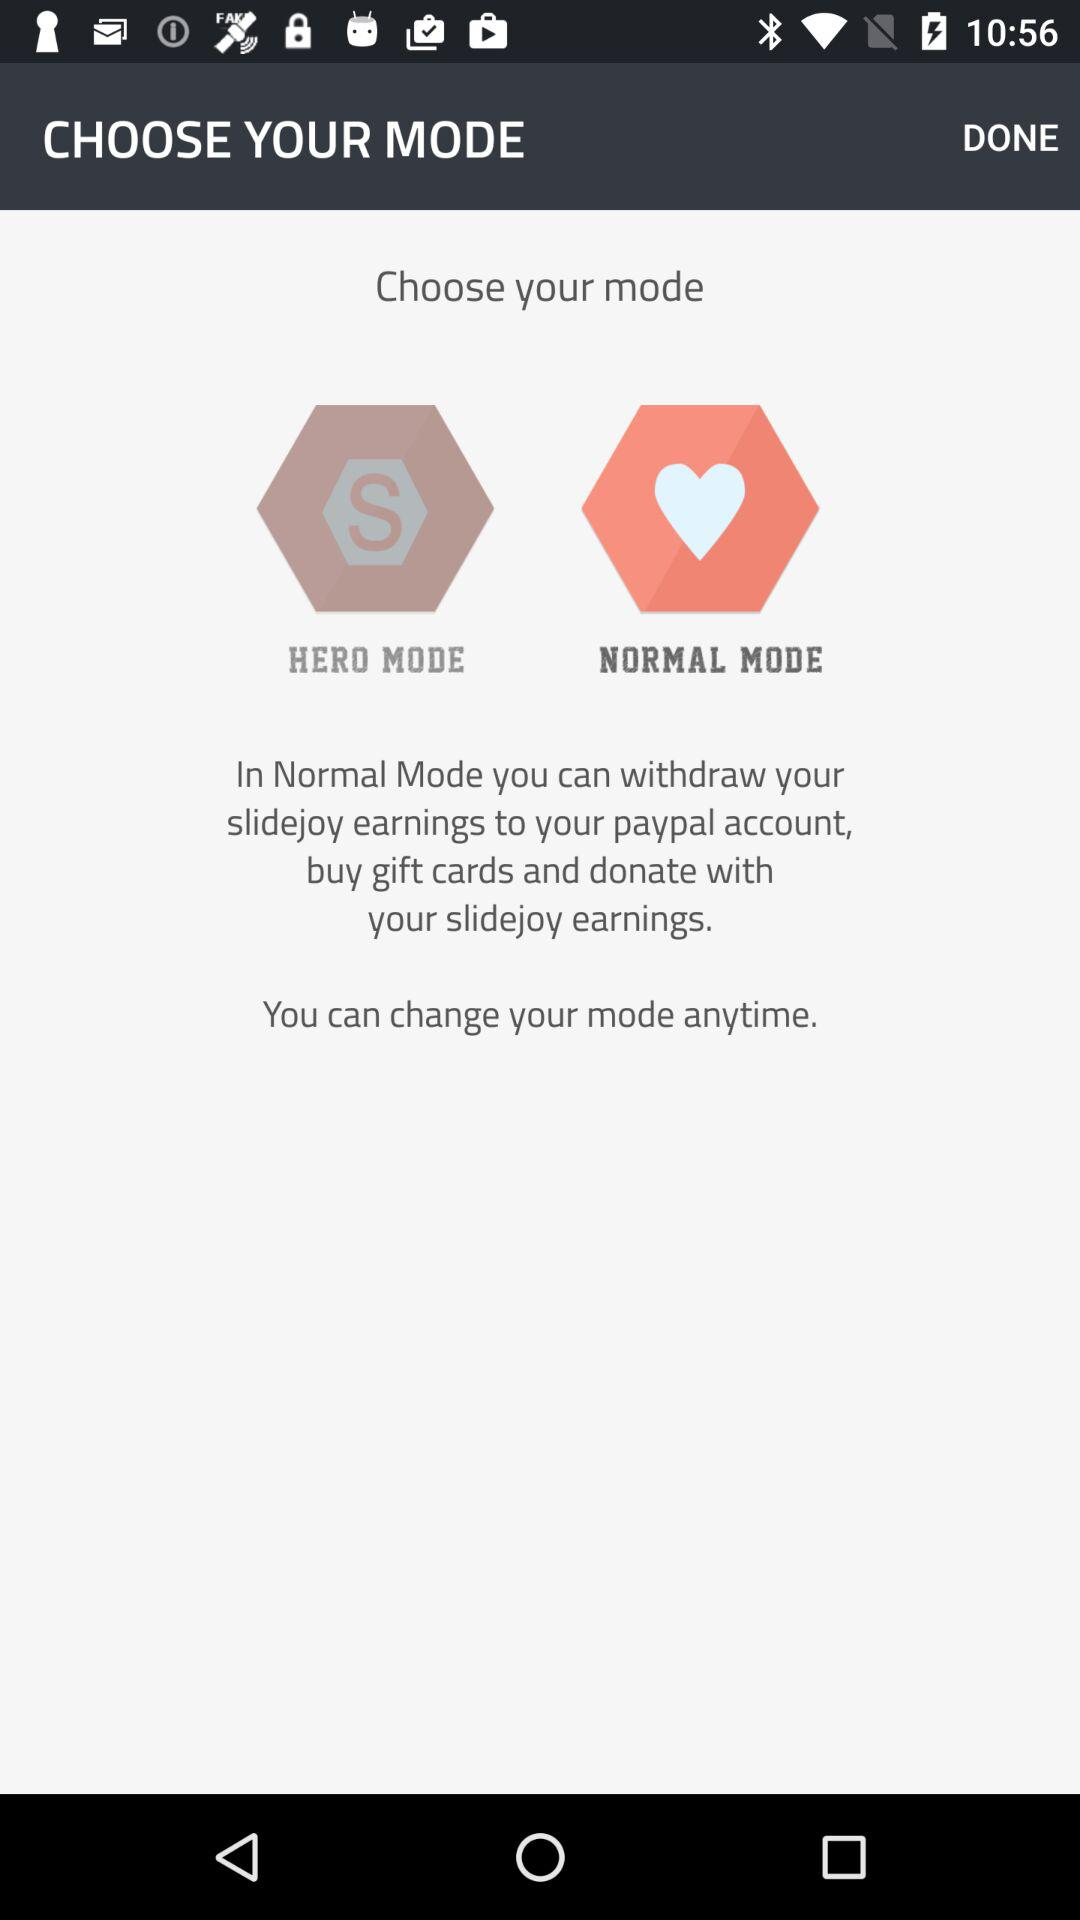What mode options are there? The options are "HERO MODE" and "NORMAL MODE". 